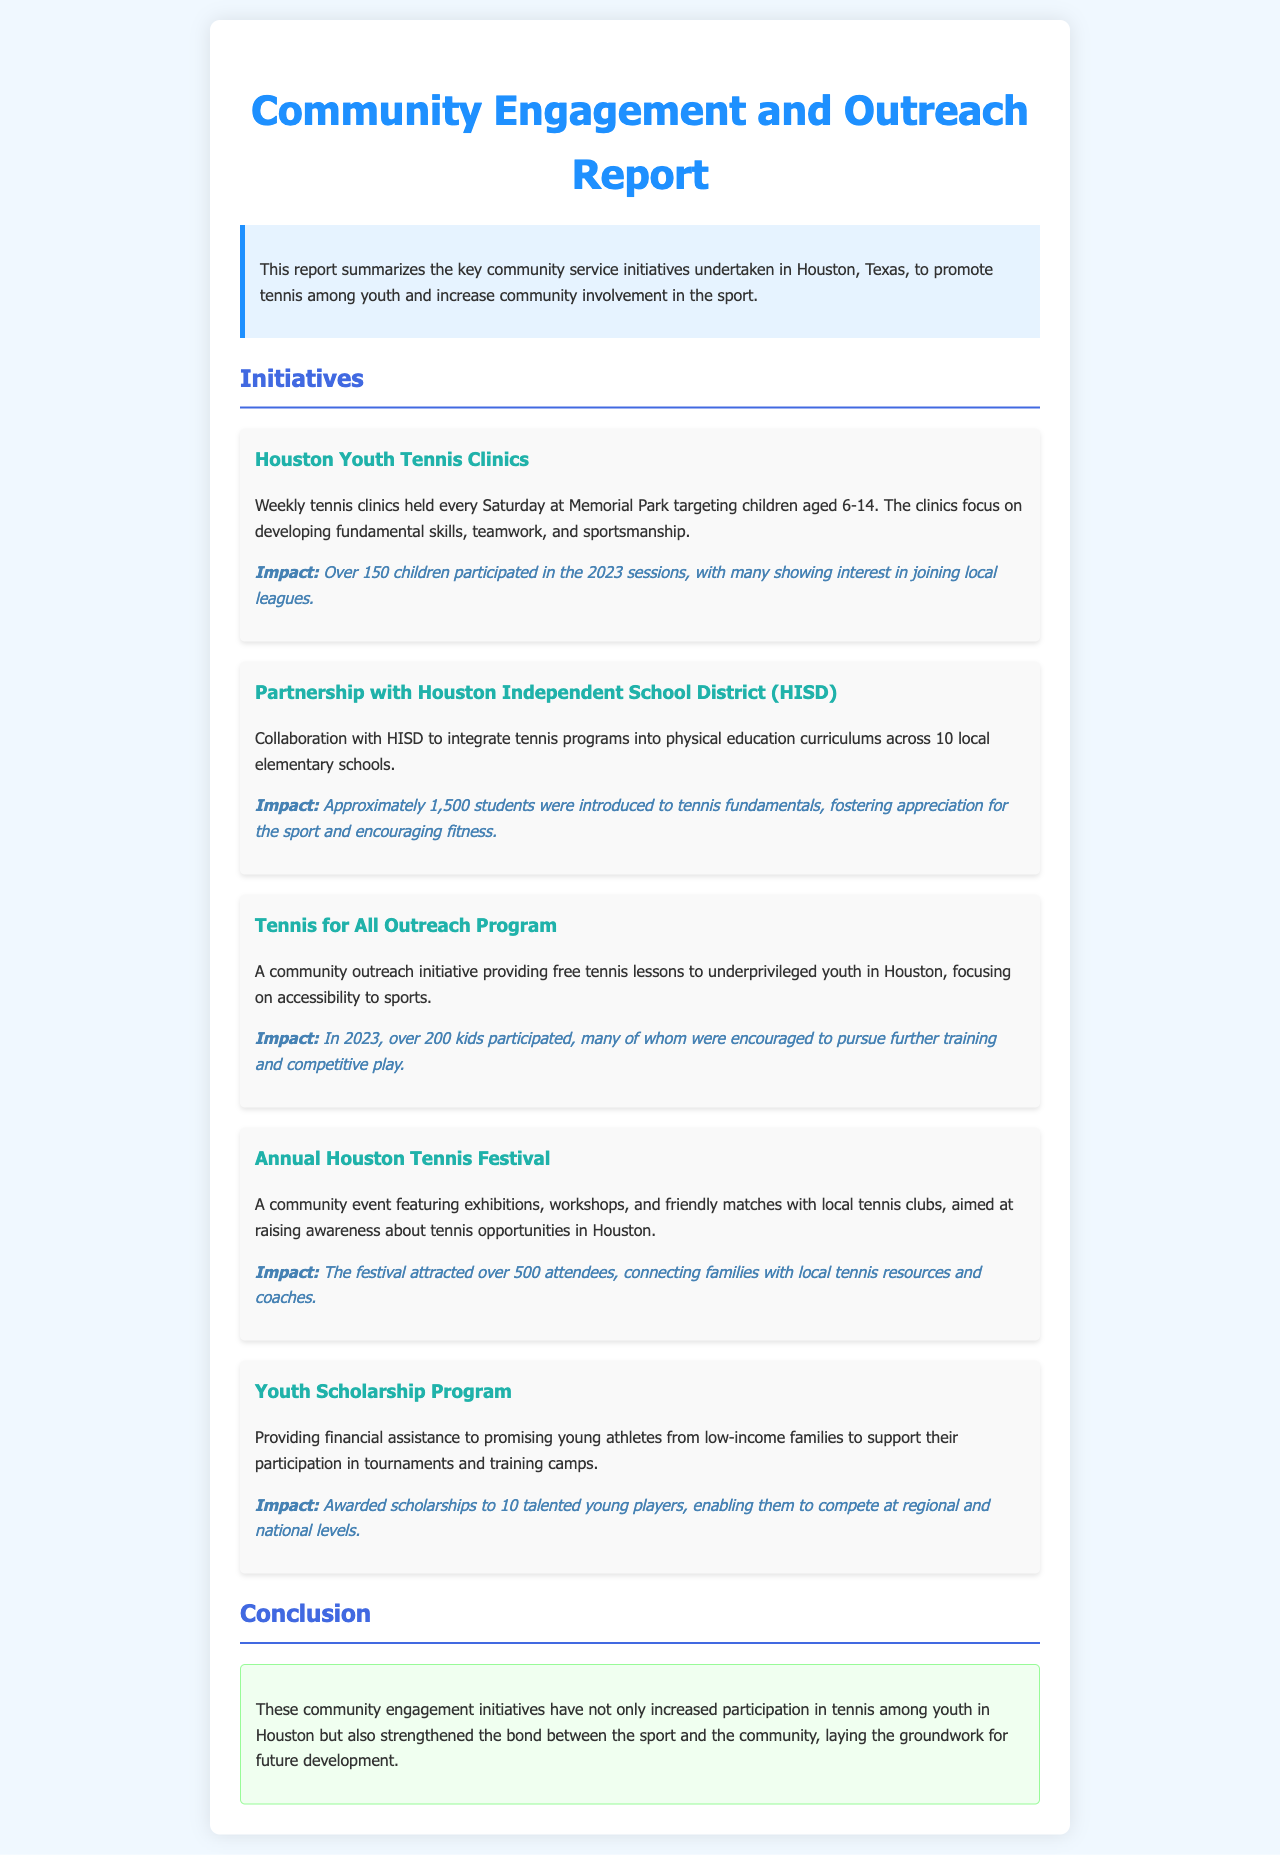What age group is targeted in the Houston Youth Tennis Clinics? The clinics focus on developing skills for children aged 6-14, as stated in the initiative description.
Answer: 6-14 How many students were introduced to tennis through the HISD partnership? The impact section notes that approximately 1,500 students were introduced to tennis fundamentals.
Answer: 1,500 What is the name of the outreach program that provides free tennis lessons? The program designed to provide free tennis lessons is mentioned as the Tennis for All Outreach Program.
Answer: Tennis for All Outreach Program How many scholarships were awarded in the Youth Scholarship Program? The document states that scholarships were awarded to 10 young players.
Answer: 10 What was the attendance at the Annual Houston Tennis Festival? The festival's impact states that it attracted over 500 attendees.
Answer: 500 Which initiative focuses on underprivileged youth in Houston? The initiative providing free lessons to underprivileged youth is the Tennis for All Outreach Program.
Answer: Tennis for All Outreach Program What key value is emphasized in the Houston Youth Tennis Clinics? The clinics emphasize developing fundamental skills, teamwork, and sportsmanship, as highlighted in the initiative description.
Answer: Sportsmanship What was the primary goal of the Annual Houston Tennis Festival? The festival aimed at raising awareness about tennis opportunities in Houston, according to the initiative description.
Answer: Raising awareness What location hosts the weekly tennis clinics? The document indicates that the tennis clinics are held at Memorial Park.
Answer: Memorial Park 